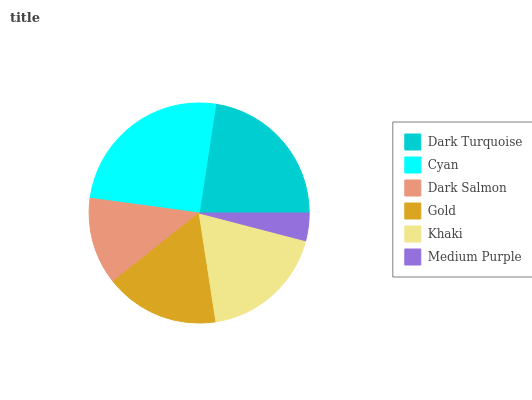Is Medium Purple the minimum?
Answer yes or no. Yes. Is Cyan the maximum?
Answer yes or no. Yes. Is Dark Salmon the minimum?
Answer yes or no. No. Is Dark Salmon the maximum?
Answer yes or no. No. Is Cyan greater than Dark Salmon?
Answer yes or no. Yes. Is Dark Salmon less than Cyan?
Answer yes or no. Yes. Is Dark Salmon greater than Cyan?
Answer yes or no. No. Is Cyan less than Dark Salmon?
Answer yes or no. No. Is Khaki the high median?
Answer yes or no. Yes. Is Gold the low median?
Answer yes or no. Yes. Is Dark Turquoise the high median?
Answer yes or no. No. Is Cyan the low median?
Answer yes or no. No. 